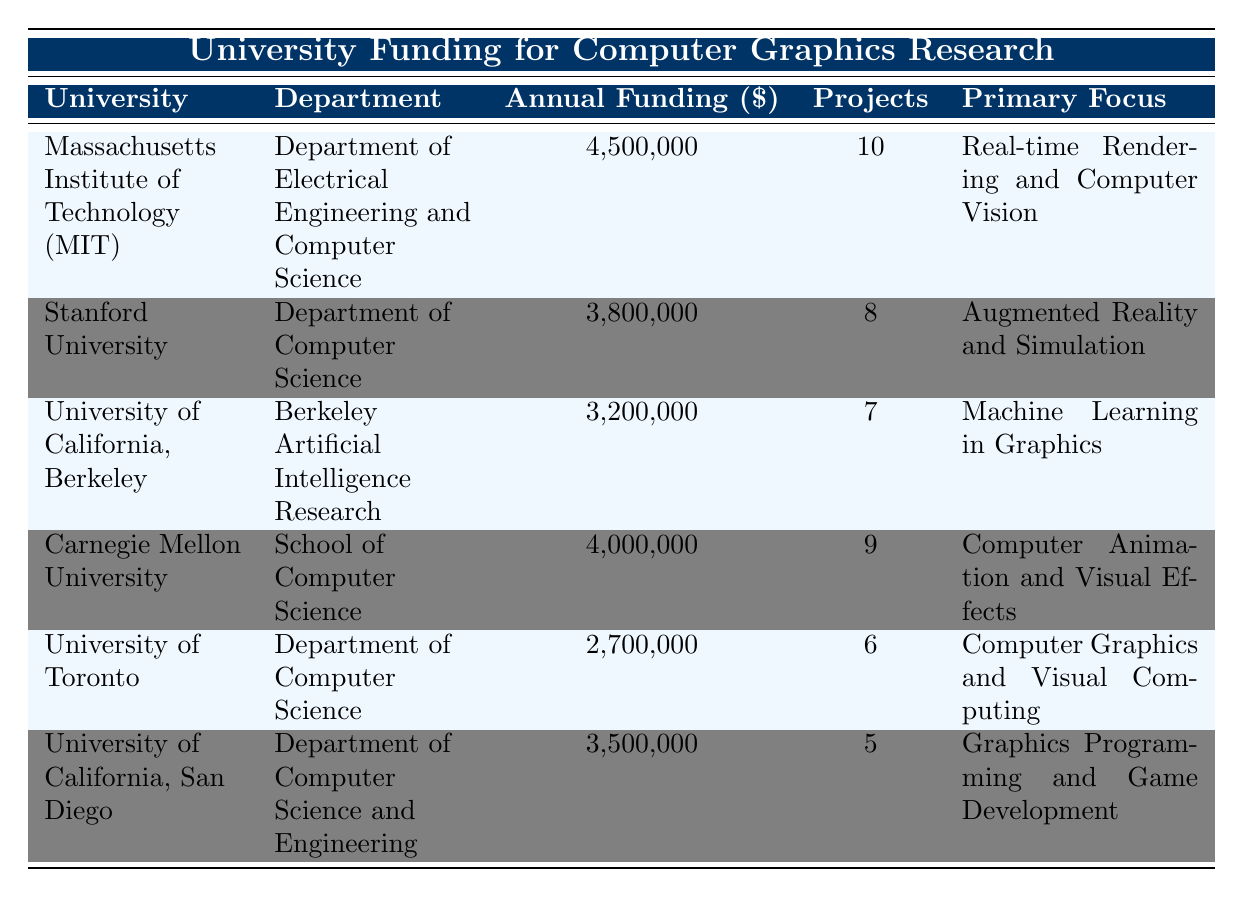What is the annual funding for Stanford University? The table lists the annual funding for each university. For Stanford University, the annual funding is mentioned in the corresponding row as 3,800,000.
Answer: 3,800,000 Which university has the highest annual funding? By comparing the annual funding listed for each university, Massachusetts Institute of Technology (MIT) is shown to have the highest funding at 4,500,000.
Answer: Massachusetts Institute of Technology (MIT) What is the total annual funding for all universities listed? The total annual funding can be calculated by summing up the values: 4,500,000 + 3,800,000 + 3,200,000 + 4,000,000 + 2,700,000 + 3,500,000 = 21,700,000.
Answer: 21,700,000 Is the primary focus of University of Toronto related to graphics programming? By checking the primary focus listed for University of Toronto, it is specified as "Computer Graphics and Visual Computing," which is related to graphics but not specifically about programming. Therefore, the answer is no.
Answer: No What is the average number of projects across all universities? To find the average number of projects, first, sum the number of projects: 10 + 8 + 7 + 9 + 6 + 5 = 45. Then, divide by the number of universities, which is 6: 45 / 6 = 7.5.
Answer: 7.5 